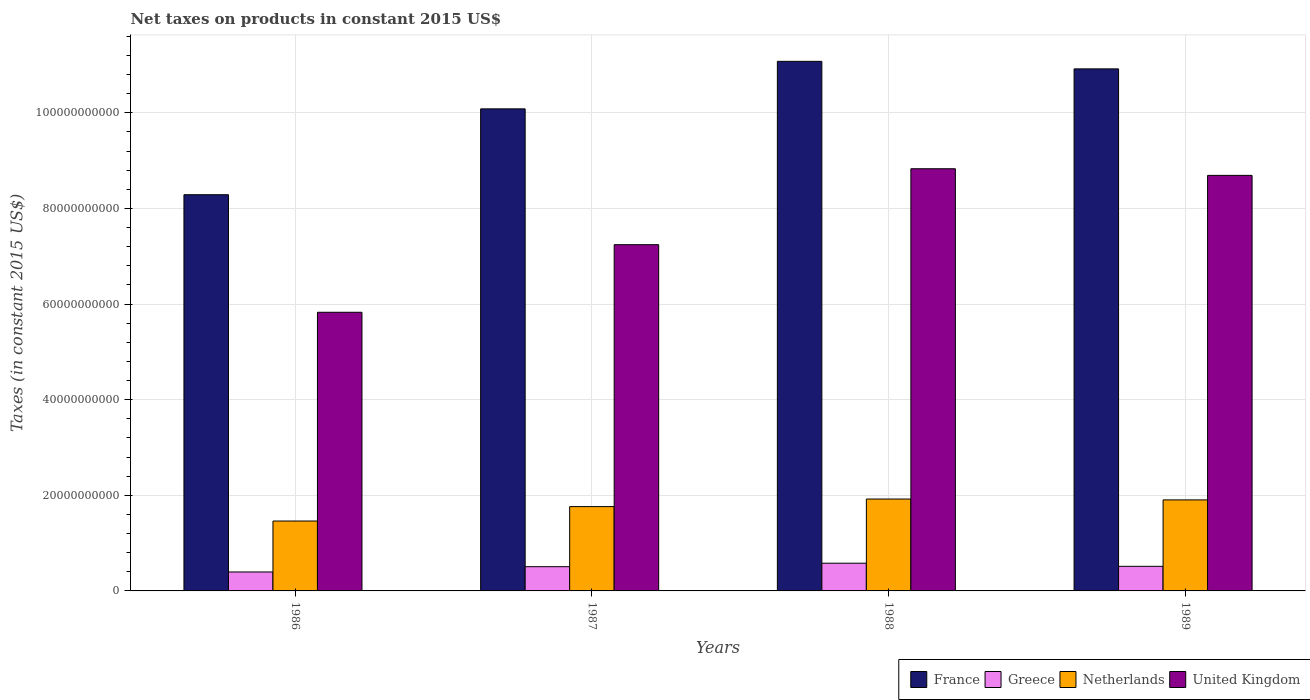How many different coloured bars are there?
Provide a succinct answer. 4. Are the number of bars per tick equal to the number of legend labels?
Make the answer very short. Yes. Are the number of bars on each tick of the X-axis equal?
Offer a very short reply. Yes. How many bars are there on the 2nd tick from the left?
Your response must be concise. 4. In how many cases, is the number of bars for a given year not equal to the number of legend labels?
Ensure brevity in your answer.  0. What is the net taxes on products in United Kingdom in 1987?
Your response must be concise. 7.24e+1. Across all years, what is the maximum net taxes on products in United Kingdom?
Ensure brevity in your answer.  8.83e+1. Across all years, what is the minimum net taxes on products in France?
Keep it short and to the point. 8.29e+1. In which year was the net taxes on products in Netherlands maximum?
Ensure brevity in your answer.  1988. In which year was the net taxes on products in Netherlands minimum?
Offer a terse response. 1986. What is the total net taxes on products in France in the graph?
Provide a succinct answer. 4.04e+11. What is the difference between the net taxes on products in France in 1986 and that in 1987?
Offer a very short reply. -1.80e+1. What is the difference between the net taxes on products in Netherlands in 1986 and the net taxes on products in Greece in 1989?
Ensure brevity in your answer.  9.48e+09. What is the average net taxes on products in Greece per year?
Keep it short and to the point. 4.99e+09. In the year 1987, what is the difference between the net taxes on products in Netherlands and net taxes on products in Greece?
Offer a very short reply. 1.26e+1. In how many years, is the net taxes on products in Netherlands greater than 84000000000 US$?
Ensure brevity in your answer.  0. What is the ratio of the net taxes on products in Greece in 1988 to that in 1989?
Provide a short and direct response. 1.13. What is the difference between the highest and the second highest net taxes on products in United Kingdom?
Give a very brief answer. 1.39e+09. What is the difference between the highest and the lowest net taxes on products in France?
Make the answer very short. 2.79e+1. In how many years, is the net taxes on products in France greater than the average net taxes on products in France taken over all years?
Offer a terse response. 2. Is the sum of the net taxes on products in Greece in 1988 and 1989 greater than the maximum net taxes on products in Netherlands across all years?
Offer a very short reply. No. Is it the case that in every year, the sum of the net taxes on products in Greece and net taxes on products in United Kingdom is greater than the sum of net taxes on products in Netherlands and net taxes on products in France?
Provide a short and direct response. Yes. What does the 2nd bar from the left in 1989 represents?
Keep it short and to the point. Greece. Is it the case that in every year, the sum of the net taxes on products in Netherlands and net taxes on products in France is greater than the net taxes on products in Greece?
Your answer should be very brief. Yes. How many bars are there?
Your answer should be very brief. 16. Are all the bars in the graph horizontal?
Make the answer very short. No. What is the difference between two consecutive major ticks on the Y-axis?
Provide a succinct answer. 2.00e+1. Does the graph contain any zero values?
Your answer should be very brief. No. Does the graph contain grids?
Keep it short and to the point. Yes. What is the title of the graph?
Offer a very short reply. Net taxes on products in constant 2015 US$. Does "Slovenia" appear as one of the legend labels in the graph?
Provide a succinct answer. No. What is the label or title of the Y-axis?
Keep it short and to the point. Taxes (in constant 2015 US$). What is the Taxes (in constant 2015 US$) of France in 1986?
Offer a terse response. 8.29e+1. What is the Taxes (in constant 2015 US$) of Greece in 1986?
Offer a terse response. 3.96e+09. What is the Taxes (in constant 2015 US$) in Netherlands in 1986?
Make the answer very short. 1.46e+1. What is the Taxes (in constant 2015 US$) in United Kingdom in 1986?
Provide a short and direct response. 5.83e+1. What is the Taxes (in constant 2015 US$) of France in 1987?
Offer a terse response. 1.01e+11. What is the Taxes (in constant 2015 US$) in Greece in 1987?
Offer a very short reply. 5.07e+09. What is the Taxes (in constant 2015 US$) in Netherlands in 1987?
Make the answer very short. 1.76e+1. What is the Taxes (in constant 2015 US$) of United Kingdom in 1987?
Offer a terse response. 7.24e+1. What is the Taxes (in constant 2015 US$) of France in 1988?
Your answer should be compact. 1.11e+11. What is the Taxes (in constant 2015 US$) in Greece in 1988?
Keep it short and to the point. 5.80e+09. What is the Taxes (in constant 2015 US$) in Netherlands in 1988?
Keep it short and to the point. 1.92e+1. What is the Taxes (in constant 2015 US$) of United Kingdom in 1988?
Keep it short and to the point. 8.83e+1. What is the Taxes (in constant 2015 US$) in France in 1989?
Ensure brevity in your answer.  1.09e+11. What is the Taxes (in constant 2015 US$) in Greece in 1989?
Ensure brevity in your answer.  5.14e+09. What is the Taxes (in constant 2015 US$) of Netherlands in 1989?
Offer a very short reply. 1.90e+1. What is the Taxes (in constant 2015 US$) in United Kingdom in 1989?
Your response must be concise. 8.69e+1. Across all years, what is the maximum Taxes (in constant 2015 US$) in France?
Your response must be concise. 1.11e+11. Across all years, what is the maximum Taxes (in constant 2015 US$) in Greece?
Provide a short and direct response. 5.80e+09. Across all years, what is the maximum Taxes (in constant 2015 US$) in Netherlands?
Offer a very short reply. 1.92e+1. Across all years, what is the maximum Taxes (in constant 2015 US$) of United Kingdom?
Give a very brief answer. 8.83e+1. Across all years, what is the minimum Taxes (in constant 2015 US$) of France?
Your answer should be compact. 8.29e+1. Across all years, what is the minimum Taxes (in constant 2015 US$) of Greece?
Your response must be concise. 3.96e+09. Across all years, what is the minimum Taxes (in constant 2015 US$) in Netherlands?
Offer a terse response. 1.46e+1. Across all years, what is the minimum Taxes (in constant 2015 US$) in United Kingdom?
Offer a very short reply. 5.83e+1. What is the total Taxes (in constant 2015 US$) in France in the graph?
Give a very brief answer. 4.04e+11. What is the total Taxes (in constant 2015 US$) in Greece in the graph?
Your answer should be compact. 2.00e+1. What is the total Taxes (in constant 2015 US$) of Netherlands in the graph?
Keep it short and to the point. 7.05e+1. What is the total Taxes (in constant 2015 US$) in United Kingdom in the graph?
Offer a very short reply. 3.06e+11. What is the difference between the Taxes (in constant 2015 US$) in France in 1986 and that in 1987?
Ensure brevity in your answer.  -1.80e+1. What is the difference between the Taxes (in constant 2015 US$) of Greece in 1986 and that in 1987?
Your answer should be very brief. -1.10e+09. What is the difference between the Taxes (in constant 2015 US$) of Netherlands in 1986 and that in 1987?
Offer a very short reply. -3.01e+09. What is the difference between the Taxes (in constant 2015 US$) in United Kingdom in 1986 and that in 1987?
Provide a short and direct response. -1.41e+1. What is the difference between the Taxes (in constant 2015 US$) in France in 1986 and that in 1988?
Ensure brevity in your answer.  -2.79e+1. What is the difference between the Taxes (in constant 2015 US$) in Greece in 1986 and that in 1988?
Give a very brief answer. -1.83e+09. What is the difference between the Taxes (in constant 2015 US$) of Netherlands in 1986 and that in 1988?
Offer a terse response. -4.60e+09. What is the difference between the Taxes (in constant 2015 US$) of United Kingdom in 1986 and that in 1988?
Keep it short and to the point. -3.00e+1. What is the difference between the Taxes (in constant 2015 US$) of France in 1986 and that in 1989?
Your answer should be compact. -2.63e+1. What is the difference between the Taxes (in constant 2015 US$) in Greece in 1986 and that in 1989?
Offer a terse response. -1.18e+09. What is the difference between the Taxes (in constant 2015 US$) in Netherlands in 1986 and that in 1989?
Make the answer very short. -4.42e+09. What is the difference between the Taxes (in constant 2015 US$) of United Kingdom in 1986 and that in 1989?
Offer a very short reply. -2.86e+1. What is the difference between the Taxes (in constant 2015 US$) of France in 1987 and that in 1988?
Offer a terse response. -9.94e+09. What is the difference between the Taxes (in constant 2015 US$) in Greece in 1987 and that in 1988?
Your response must be concise. -7.31e+08. What is the difference between the Taxes (in constant 2015 US$) of Netherlands in 1987 and that in 1988?
Your response must be concise. -1.58e+09. What is the difference between the Taxes (in constant 2015 US$) of United Kingdom in 1987 and that in 1988?
Offer a terse response. -1.59e+1. What is the difference between the Taxes (in constant 2015 US$) in France in 1987 and that in 1989?
Make the answer very short. -8.36e+09. What is the difference between the Taxes (in constant 2015 US$) of Greece in 1987 and that in 1989?
Offer a terse response. -7.74e+07. What is the difference between the Taxes (in constant 2015 US$) in Netherlands in 1987 and that in 1989?
Ensure brevity in your answer.  -1.40e+09. What is the difference between the Taxes (in constant 2015 US$) in United Kingdom in 1987 and that in 1989?
Give a very brief answer. -1.45e+1. What is the difference between the Taxes (in constant 2015 US$) of France in 1988 and that in 1989?
Ensure brevity in your answer.  1.57e+09. What is the difference between the Taxes (in constant 2015 US$) in Greece in 1988 and that in 1989?
Give a very brief answer. 6.53e+08. What is the difference between the Taxes (in constant 2015 US$) of Netherlands in 1988 and that in 1989?
Your answer should be compact. 1.80e+08. What is the difference between the Taxes (in constant 2015 US$) of United Kingdom in 1988 and that in 1989?
Your answer should be very brief. 1.39e+09. What is the difference between the Taxes (in constant 2015 US$) of France in 1986 and the Taxes (in constant 2015 US$) of Greece in 1987?
Make the answer very short. 7.78e+1. What is the difference between the Taxes (in constant 2015 US$) in France in 1986 and the Taxes (in constant 2015 US$) in Netherlands in 1987?
Offer a terse response. 6.52e+1. What is the difference between the Taxes (in constant 2015 US$) in France in 1986 and the Taxes (in constant 2015 US$) in United Kingdom in 1987?
Provide a succinct answer. 1.05e+1. What is the difference between the Taxes (in constant 2015 US$) in Greece in 1986 and the Taxes (in constant 2015 US$) in Netherlands in 1987?
Offer a very short reply. -1.37e+1. What is the difference between the Taxes (in constant 2015 US$) in Greece in 1986 and the Taxes (in constant 2015 US$) in United Kingdom in 1987?
Offer a terse response. -6.85e+1. What is the difference between the Taxes (in constant 2015 US$) in Netherlands in 1986 and the Taxes (in constant 2015 US$) in United Kingdom in 1987?
Your answer should be very brief. -5.78e+1. What is the difference between the Taxes (in constant 2015 US$) in France in 1986 and the Taxes (in constant 2015 US$) in Greece in 1988?
Your answer should be compact. 7.71e+1. What is the difference between the Taxes (in constant 2015 US$) in France in 1986 and the Taxes (in constant 2015 US$) in Netherlands in 1988?
Ensure brevity in your answer.  6.37e+1. What is the difference between the Taxes (in constant 2015 US$) in France in 1986 and the Taxes (in constant 2015 US$) in United Kingdom in 1988?
Your response must be concise. -5.43e+09. What is the difference between the Taxes (in constant 2015 US$) in Greece in 1986 and the Taxes (in constant 2015 US$) in Netherlands in 1988?
Offer a very short reply. -1.53e+1. What is the difference between the Taxes (in constant 2015 US$) in Greece in 1986 and the Taxes (in constant 2015 US$) in United Kingdom in 1988?
Offer a terse response. -8.43e+1. What is the difference between the Taxes (in constant 2015 US$) of Netherlands in 1986 and the Taxes (in constant 2015 US$) of United Kingdom in 1988?
Give a very brief answer. -7.37e+1. What is the difference between the Taxes (in constant 2015 US$) in France in 1986 and the Taxes (in constant 2015 US$) in Greece in 1989?
Provide a short and direct response. 7.77e+1. What is the difference between the Taxes (in constant 2015 US$) in France in 1986 and the Taxes (in constant 2015 US$) in Netherlands in 1989?
Your response must be concise. 6.38e+1. What is the difference between the Taxes (in constant 2015 US$) of France in 1986 and the Taxes (in constant 2015 US$) of United Kingdom in 1989?
Offer a terse response. -4.04e+09. What is the difference between the Taxes (in constant 2015 US$) in Greece in 1986 and the Taxes (in constant 2015 US$) in Netherlands in 1989?
Your answer should be compact. -1.51e+1. What is the difference between the Taxes (in constant 2015 US$) of Greece in 1986 and the Taxes (in constant 2015 US$) of United Kingdom in 1989?
Offer a terse response. -8.30e+1. What is the difference between the Taxes (in constant 2015 US$) in Netherlands in 1986 and the Taxes (in constant 2015 US$) in United Kingdom in 1989?
Keep it short and to the point. -7.23e+1. What is the difference between the Taxes (in constant 2015 US$) of France in 1987 and the Taxes (in constant 2015 US$) of Greece in 1988?
Offer a very short reply. 9.50e+1. What is the difference between the Taxes (in constant 2015 US$) of France in 1987 and the Taxes (in constant 2015 US$) of Netherlands in 1988?
Ensure brevity in your answer.  8.16e+1. What is the difference between the Taxes (in constant 2015 US$) in France in 1987 and the Taxes (in constant 2015 US$) in United Kingdom in 1988?
Your response must be concise. 1.25e+1. What is the difference between the Taxes (in constant 2015 US$) in Greece in 1987 and the Taxes (in constant 2015 US$) in Netherlands in 1988?
Your answer should be very brief. -1.42e+1. What is the difference between the Taxes (in constant 2015 US$) in Greece in 1987 and the Taxes (in constant 2015 US$) in United Kingdom in 1988?
Make the answer very short. -8.32e+1. What is the difference between the Taxes (in constant 2015 US$) of Netherlands in 1987 and the Taxes (in constant 2015 US$) of United Kingdom in 1988?
Make the answer very short. -7.07e+1. What is the difference between the Taxes (in constant 2015 US$) of France in 1987 and the Taxes (in constant 2015 US$) of Greece in 1989?
Offer a very short reply. 9.57e+1. What is the difference between the Taxes (in constant 2015 US$) in France in 1987 and the Taxes (in constant 2015 US$) in Netherlands in 1989?
Provide a short and direct response. 8.18e+1. What is the difference between the Taxes (in constant 2015 US$) of France in 1987 and the Taxes (in constant 2015 US$) of United Kingdom in 1989?
Keep it short and to the point. 1.39e+1. What is the difference between the Taxes (in constant 2015 US$) of Greece in 1987 and the Taxes (in constant 2015 US$) of Netherlands in 1989?
Your response must be concise. -1.40e+1. What is the difference between the Taxes (in constant 2015 US$) in Greece in 1987 and the Taxes (in constant 2015 US$) in United Kingdom in 1989?
Give a very brief answer. -8.19e+1. What is the difference between the Taxes (in constant 2015 US$) in Netherlands in 1987 and the Taxes (in constant 2015 US$) in United Kingdom in 1989?
Give a very brief answer. -6.93e+1. What is the difference between the Taxes (in constant 2015 US$) in France in 1988 and the Taxes (in constant 2015 US$) in Greece in 1989?
Your answer should be compact. 1.06e+11. What is the difference between the Taxes (in constant 2015 US$) of France in 1988 and the Taxes (in constant 2015 US$) of Netherlands in 1989?
Your response must be concise. 9.17e+1. What is the difference between the Taxes (in constant 2015 US$) of France in 1988 and the Taxes (in constant 2015 US$) of United Kingdom in 1989?
Make the answer very short. 2.39e+1. What is the difference between the Taxes (in constant 2015 US$) of Greece in 1988 and the Taxes (in constant 2015 US$) of Netherlands in 1989?
Provide a short and direct response. -1.32e+1. What is the difference between the Taxes (in constant 2015 US$) in Greece in 1988 and the Taxes (in constant 2015 US$) in United Kingdom in 1989?
Offer a terse response. -8.11e+1. What is the difference between the Taxes (in constant 2015 US$) of Netherlands in 1988 and the Taxes (in constant 2015 US$) of United Kingdom in 1989?
Ensure brevity in your answer.  -6.77e+1. What is the average Taxes (in constant 2015 US$) in France per year?
Your answer should be compact. 1.01e+11. What is the average Taxes (in constant 2015 US$) in Greece per year?
Your answer should be compact. 4.99e+09. What is the average Taxes (in constant 2015 US$) in Netherlands per year?
Your response must be concise. 1.76e+1. What is the average Taxes (in constant 2015 US$) in United Kingdom per year?
Provide a succinct answer. 7.65e+1. In the year 1986, what is the difference between the Taxes (in constant 2015 US$) in France and Taxes (in constant 2015 US$) in Greece?
Your response must be concise. 7.89e+1. In the year 1986, what is the difference between the Taxes (in constant 2015 US$) of France and Taxes (in constant 2015 US$) of Netherlands?
Provide a short and direct response. 6.83e+1. In the year 1986, what is the difference between the Taxes (in constant 2015 US$) in France and Taxes (in constant 2015 US$) in United Kingdom?
Offer a very short reply. 2.46e+1. In the year 1986, what is the difference between the Taxes (in constant 2015 US$) of Greece and Taxes (in constant 2015 US$) of Netherlands?
Offer a terse response. -1.07e+1. In the year 1986, what is the difference between the Taxes (in constant 2015 US$) in Greece and Taxes (in constant 2015 US$) in United Kingdom?
Ensure brevity in your answer.  -5.43e+1. In the year 1986, what is the difference between the Taxes (in constant 2015 US$) in Netherlands and Taxes (in constant 2015 US$) in United Kingdom?
Offer a terse response. -4.37e+1. In the year 1987, what is the difference between the Taxes (in constant 2015 US$) in France and Taxes (in constant 2015 US$) in Greece?
Provide a short and direct response. 9.58e+1. In the year 1987, what is the difference between the Taxes (in constant 2015 US$) in France and Taxes (in constant 2015 US$) in Netherlands?
Your answer should be compact. 8.32e+1. In the year 1987, what is the difference between the Taxes (in constant 2015 US$) in France and Taxes (in constant 2015 US$) in United Kingdom?
Offer a terse response. 2.84e+1. In the year 1987, what is the difference between the Taxes (in constant 2015 US$) in Greece and Taxes (in constant 2015 US$) in Netherlands?
Keep it short and to the point. -1.26e+1. In the year 1987, what is the difference between the Taxes (in constant 2015 US$) of Greece and Taxes (in constant 2015 US$) of United Kingdom?
Provide a short and direct response. -6.74e+1. In the year 1987, what is the difference between the Taxes (in constant 2015 US$) of Netherlands and Taxes (in constant 2015 US$) of United Kingdom?
Provide a succinct answer. -5.48e+1. In the year 1988, what is the difference between the Taxes (in constant 2015 US$) in France and Taxes (in constant 2015 US$) in Greece?
Your answer should be compact. 1.05e+11. In the year 1988, what is the difference between the Taxes (in constant 2015 US$) of France and Taxes (in constant 2015 US$) of Netherlands?
Offer a very short reply. 9.16e+1. In the year 1988, what is the difference between the Taxes (in constant 2015 US$) in France and Taxes (in constant 2015 US$) in United Kingdom?
Provide a short and direct response. 2.25e+1. In the year 1988, what is the difference between the Taxes (in constant 2015 US$) of Greece and Taxes (in constant 2015 US$) of Netherlands?
Give a very brief answer. -1.34e+1. In the year 1988, what is the difference between the Taxes (in constant 2015 US$) in Greece and Taxes (in constant 2015 US$) in United Kingdom?
Give a very brief answer. -8.25e+1. In the year 1988, what is the difference between the Taxes (in constant 2015 US$) of Netherlands and Taxes (in constant 2015 US$) of United Kingdom?
Offer a very short reply. -6.91e+1. In the year 1989, what is the difference between the Taxes (in constant 2015 US$) of France and Taxes (in constant 2015 US$) of Greece?
Give a very brief answer. 1.04e+11. In the year 1989, what is the difference between the Taxes (in constant 2015 US$) of France and Taxes (in constant 2015 US$) of Netherlands?
Provide a succinct answer. 9.02e+1. In the year 1989, what is the difference between the Taxes (in constant 2015 US$) of France and Taxes (in constant 2015 US$) of United Kingdom?
Your response must be concise. 2.23e+1. In the year 1989, what is the difference between the Taxes (in constant 2015 US$) in Greece and Taxes (in constant 2015 US$) in Netherlands?
Keep it short and to the point. -1.39e+1. In the year 1989, what is the difference between the Taxes (in constant 2015 US$) of Greece and Taxes (in constant 2015 US$) of United Kingdom?
Provide a short and direct response. -8.18e+1. In the year 1989, what is the difference between the Taxes (in constant 2015 US$) in Netherlands and Taxes (in constant 2015 US$) in United Kingdom?
Ensure brevity in your answer.  -6.79e+1. What is the ratio of the Taxes (in constant 2015 US$) in France in 1986 to that in 1987?
Give a very brief answer. 0.82. What is the ratio of the Taxes (in constant 2015 US$) in Greece in 1986 to that in 1987?
Your answer should be very brief. 0.78. What is the ratio of the Taxes (in constant 2015 US$) of Netherlands in 1986 to that in 1987?
Provide a succinct answer. 0.83. What is the ratio of the Taxes (in constant 2015 US$) in United Kingdom in 1986 to that in 1987?
Provide a short and direct response. 0.8. What is the ratio of the Taxes (in constant 2015 US$) in France in 1986 to that in 1988?
Ensure brevity in your answer.  0.75. What is the ratio of the Taxes (in constant 2015 US$) in Greece in 1986 to that in 1988?
Provide a succinct answer. 0.68. What is the ratio of the Taxes (in constant 2015 US$) in Netherlands in 1986 to that in 1988?
Give a very brief answer. 0.76. What is the ratio of the Taxes (in constant 2015 US$) of United Kingdom in 1986 to that in 1988?
Keep it short and to the point. 0.66. What is the ratio of the Taxes (in constant 2015 US$) in France in 1986 to that in 1989?
Your answer should be very brief. 0.76. What is the ratio of the Taxes (in constant 2015 US$) of Greece in 1986 to that in 1989?
Give a very brief answer. 0.77. What is the ratio of the Taxes (in constant 2015 US$) in Netherlands in 1986 to that in 1989?
Your answer should be very brief. 0.77. What is the ratio of the Taxes (in constant 2015 US$) in United Kingdom in 1986 to that in 1989?
Your answer should be very brief. 0.67. What is the ratio of the Taxes (in constant 2015 US$) of France in 1987 to that in 1988?
Ensure brevity in your answer.  0.91. What is the ratio of the Taxes (in constant 2015 US$) of Greece in 1987 to that in 1988?
Your response must be concise. 0.87. What is the ratio of the Taxes (in constant 2015 US$) of Netherlands in 1987 to that in 1988?
Give a very brief answer. 0.92. What is the ratio of the Taxes (in constant 2015 US$) in United Kingdom in 1987 to that in 1988?
Offer a very short reply. 0.82. What is the ratio of the Taxes (in constant 2015 US$) of France in 1987 to that in 1989?
Give a very brief answer. 0.92. What is the ratio of the Taxes (in constant 2015 US$) of Greece in 1987 to that in 1989?
Provide a short and direct response. 0.98. What is the ratio of the Taxes (in constant 2015 US$) of Netherlands in 1987 to that in 1989?
Your answer should be compact. 0.93. What is the ratio of the Taxes (in constant 2015 US$) of United Kingdom in 1987 to that in 1989?
Ensure brevity in your answer.  0.83. What is the ratio of the Taxes (in constant 2015 US$) of France in 1988 to that in 1989?
Make the answer very short. 1.01. What is the ratio of the Taxes (in constant 2015 US$) of Greece in 1988 to that in 1989?
Your response must be concise. 1.13. What is the ratio of the Taxes (in constant 2015 US$) in Netherlands in 1988 to that in 1989?
Your answer should be very brief. 1.01. What is the difference between the highest and the second highest Taxes (in constant 2015 US$) in France?
Give a very brief answer. 1.57e+09. What is the difference between the highest and the second highest Taxes (in constant 2015 US$) of Greece?
Offer a terse response. 6.53e+08. What is the difference between the highest and the second highest Taxes (in constant 2015 US$) in Netherlands?
Your response must be concise. 1.80e+08. What is the difference between the highest and the second highest Taxes (in constant 2015 US$) of United Kingdom?
Provide a succinct answer. 1.39e+09. What is the difference between the highest and the lowest Taxes (in constant 2015 US$) in France?
Offer a very short reply. 2.79e+1. What is the difference between the highest and the lowest Taxes (in constant 2015 US$) of Greece?
Make the answer very short. 1.83e+09. What is the difference between the highest and the lowest Taxes (in constant 2015 US$) of Netherlands?
Make the answer very short. 4.60e+09. What is the difference between the highest and the lowest Taxes (in constant 2015 US$) of United Kingdom?
Offer a very short reply. 3.00e+1. 